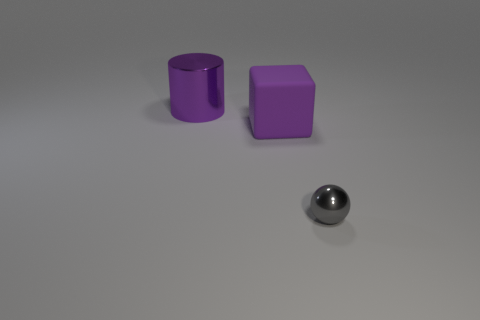Are there any other things that are the same size as the sphere?
Provide a succinct answer. No. What number of big objects are yellow metallic objects or gray metal objects?
Your response must be concise. 0. How many other large purple cylinders are made of the same material as the purple cylinder?
Provide a succinct answer. 0. There is a shiny object behind the small gray metallic sphere; what size is it?
Make the answer very short. Large. There is a purple thing in front of the shiny thing that is left of the tiny object; what is its shape?
Keep it short and to the point. Cube. There is a shiny object to the right of the shiny thing that is behind the small gray ball; how many big purple objects are to the right of it?
Give a very brief answer. 0. Are there fewer small shiny things right of the metal ball than gray cylinders?
Make the answer very short. No. Is there any other thing that is the same shape as the gray metallic object?
Your answer should be very brief. No. The big purple object that is in front of the big purple cylinder has what shape?
Your answer should be compact. Cube. What is the shape of the big object that is behind the large purple thing right of the metallic object behind the tiny gray shiny thing?
Your response must be concise. Cylinder. 